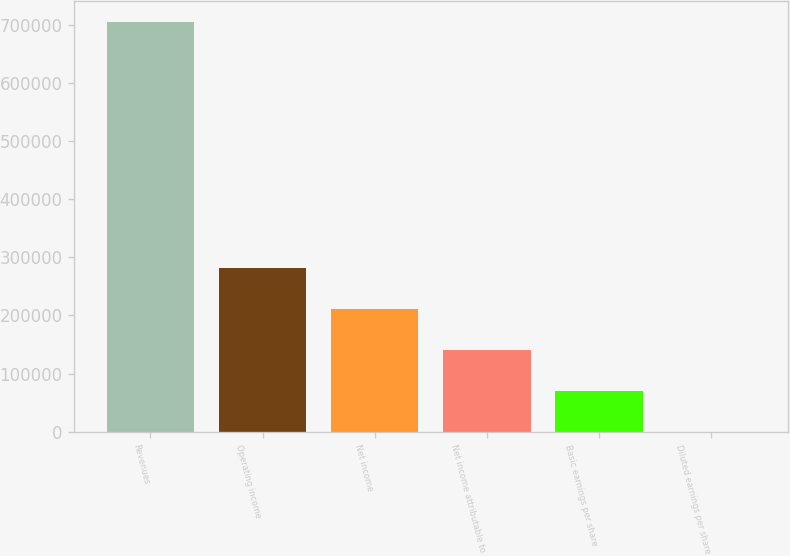Convert chart. <chart><loc_0><loc_0><loc_500><loc_500><bar_chart><fcel>Revenues<fcel>Operating income<fcel>Net income<fcel>Net income attributable to<fcel>Basic earnings per share<fcel>Diluted earnings per share<nl><fcel>706549<fcel>282620<fcel>211965<fcel>141310<fcel>70655.3<fcel>0.49<nl></chart> 